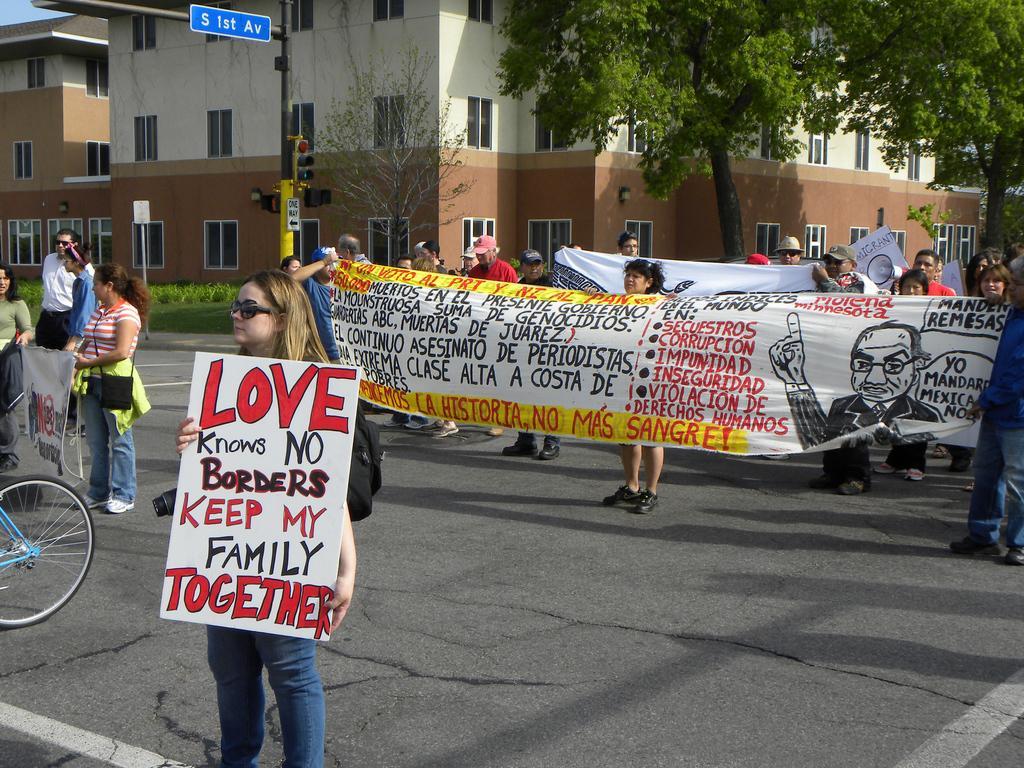Describe this image in one or two sentences. In the foreground of the image there is a lady holding a placard with some text on it. In the background of the image there are people holding banners. There is a building. There are trees. There is a pole with sign board. At the bottom of the image there is road. To the left side of the image there is a Tyre of a bicycle. 